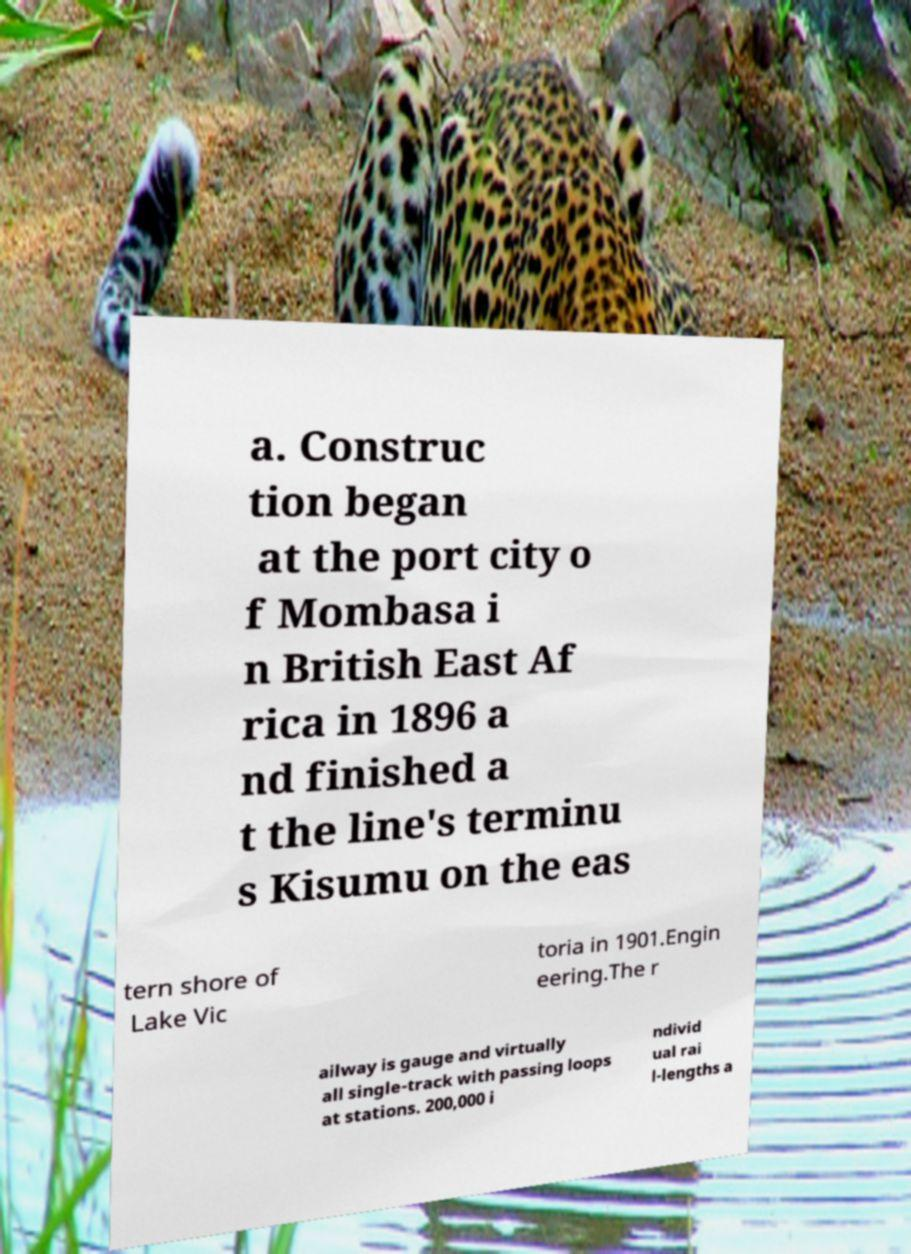Could you extract and type out the text from this image? a. Construc tion began at the port city o f Mombasa i n British East Af rica in 1896 a nd finished a t the line's terminu s Kisumu on the eas tern shore of Lake Vic toria in 1901.Engin eering.The r ailway is gauge and virtually all single-track with passing loops at stations. 200,000 i ndivid ual rai l-lengths a 